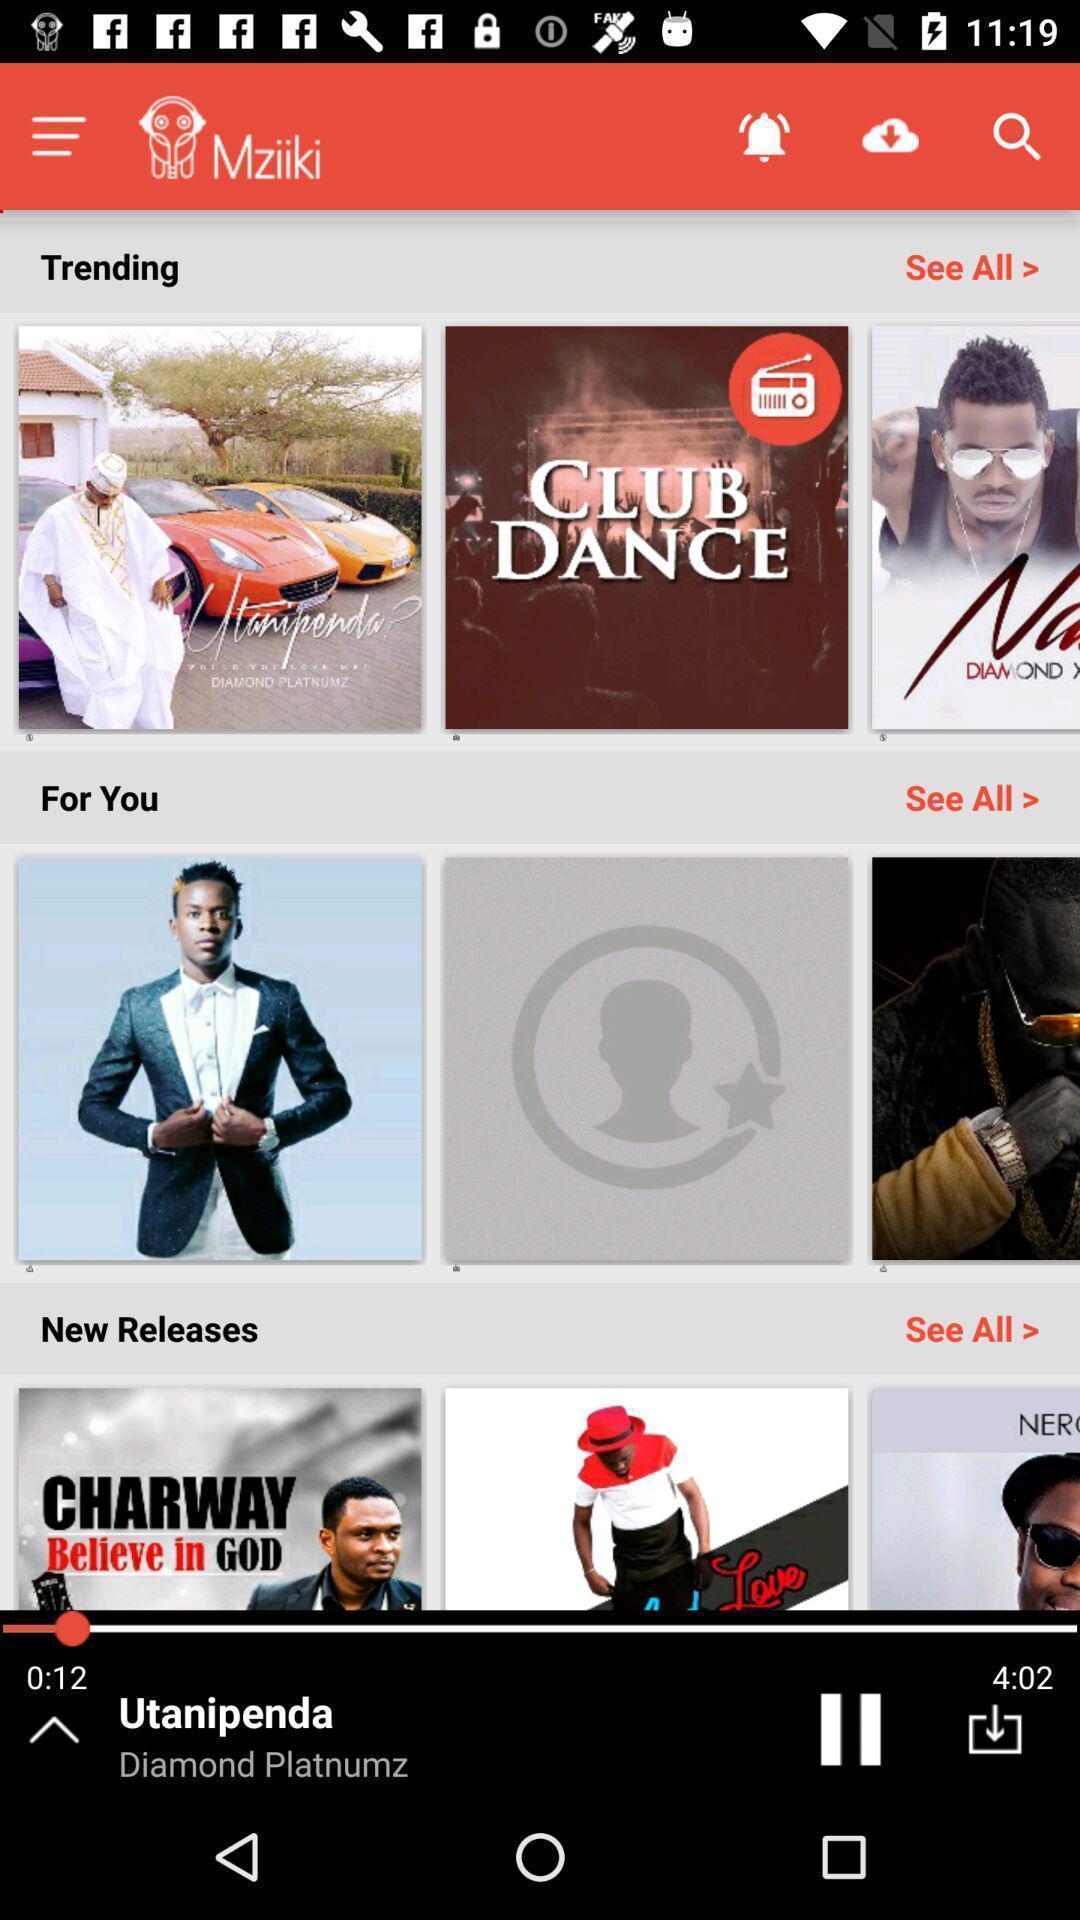Describe the visual elements of this screenshot. Page with different collection of songs of a music app. 